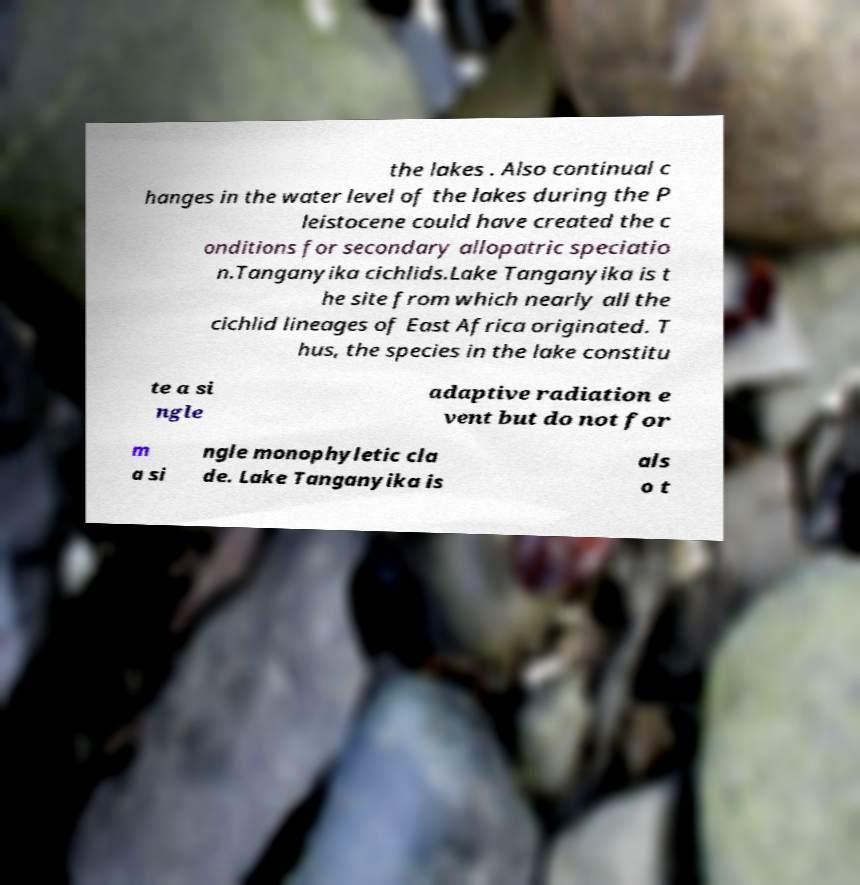Could you extract and type out the text from this image? the lakes . Also continual c hanges in the water level of the lakes during the P leistocene could have created the c onditions for secondary allopatric speciatio n.Tanganyika cichlids.Lake Tanganyika is t he site from which nearly all the cichlid lineages of East Africa originated. T hus, the species in the lake constitu te a si ngle adaptive radiation e vent but do not for m a si ngle monophyletic cla de. Lake Tanganyika is als o t 